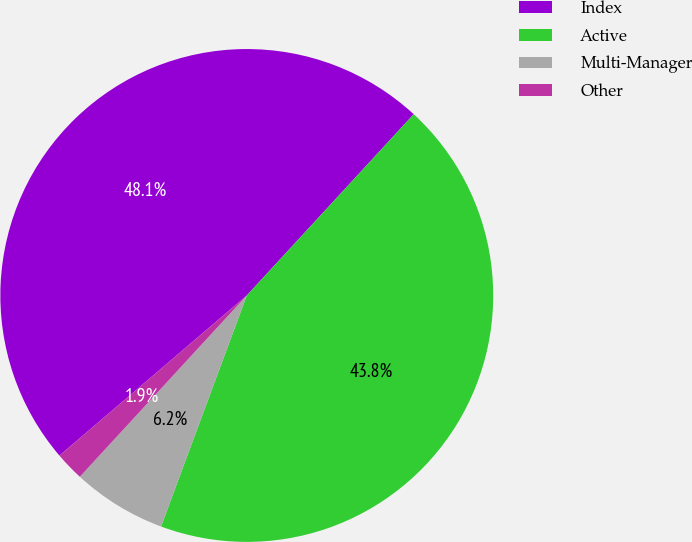<chart> <loc_0><loc_0><loc_500><loc_500><pie_chart><fcel>Index<fcel>Active<fcel>Multi-Manager<fcel>Other<nl><fcel>48.1%<fcel>43.81%<fcel>6.19%<fcel>1.9%<nl></chart> 